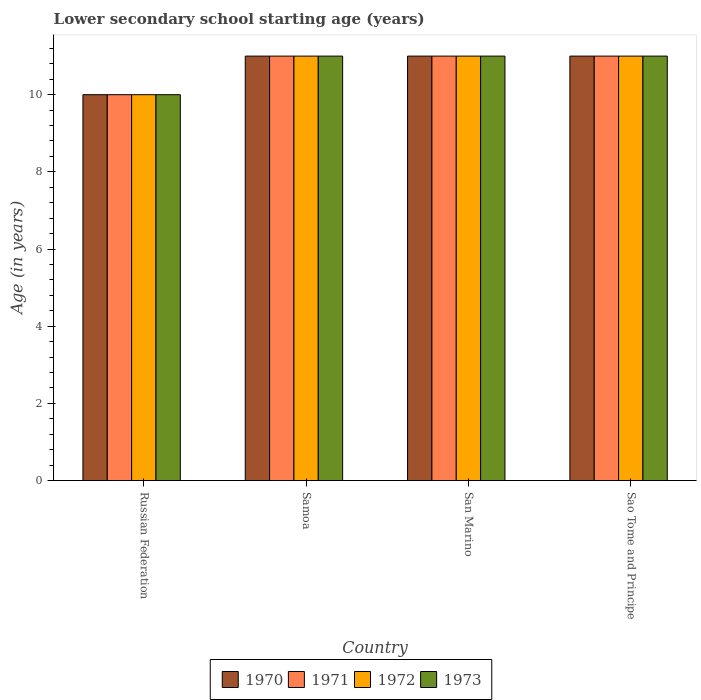How many different coloured bars are there?
Your answer should be compact. 4. How many groups of bars are there?
Offer a very short reply. 4. Are the number of bars per tick equal to the number of legend labels?
Keep it short and to the point. Yes. How many bars are there on the 3rd tick from the right?
Make the answer very short. 4. What is the label of the 4th group of bars from the left?
Your answer should be very brief. Sao Tome and Principe. What is the lower secondary school starting age of children in 1970 in Sao Tome and Principe?
Keep it short and to the point. 11. Across all countries, what is the maximum lower secondary school starting age of children in 1970?
Make the answer very short. 11. Across all countries, what is the minimum lower secondary school starting age of children in 1970?
Your response must be concise. 10. In which country was the lower secondary school starting age of children in 1972 maximum?
Your answer should be compact. Samoa. In which country was the lower secondary school starting age of children in 1973 minimum?
Your response must be concise. Russian Federation. What is the difference between the lower secondary school starting age of children in 1970 in Sao Tome and Principe and the lower secondary school starting age of children in 1972 in Samoa?
Offer a terse response. 0. What is the average lower secondary school starting age of children in 1973 per country?
Offer a terse response. 10.75. What is the difference between the lower secondary school starting age of children of/in 1972 and lower secondary school starting age of children of/in 1970 in San Marino?
Provide a succinct answer. 0. Is the difference between the lower secondary school starting age of children in 1972 in San Marino and Sao Tome and Principe greater than the difference between the lower secondary school starting age of children in 1970 in San Marino and Sao Tome and Principe?
Offer a terse response. No. What is the difference between the highest and the lowest lower secondary school starting age of children in 1973?
Provide a succinct answer. 1. Is the sum of the lower secondary school starting age of children in 1972 in Samoa and Sao Tome and Principe greater than the maximum lower secondary school starting age of children in 1971 across all countries?
Your answer should be compact. Yes. Is it the case that in every country, the sum of the lower secondary school starting age of children in 1971 and lower secondary school starting age of children in 1970 is greater than the sum of lower secondary school starting age of children in 1973 and lower secondary school starting age of children in 1972?
Make the answer very short. No. What does the 2nd bar from the left in Sao Tome and Principe represents?
Make the answer very short. 1971. What does the 3rd bar from the right in San Marino represents?
Your answer should be compact. 1971. What is the difference between two consecutive major ticks on the Y-axis?
Give a very brief answer. 2. Does the graph contain any zero values?
Provide a succinct answer. No. Does the graph contain grids?
Offer a very short reply. No. Where does the legend appear in the graph?
Your answer should be compact. Bottom center. How many legend labels are there?
Offer a terse response. 4. What is the title of the graph?
Provide a short and direct response. Lower secondary school starting age (years). Does "2000" appear as one of the legend labels in the graph?
Your answer should be very brief. No. What is the label or title of the Y-axis?
Make the answer very short. Age (in years). What is the Age (in years) of 1972 in Russian Federation?
Keep it short and to the point. 10. What is the Age (in years) in 1971 in Samoa?
Make the answer very short. 11. What is the Age (in years) of 1973 in Samoa?
Offer a very short reply. 11. What is the Age (in years) of 1971 in San Marino?
Offer a terse response. 11. What is the Age (in years) in 1970 in Sao Tome and Principe?
Provide a succinct answer. 11. Across all countries, what is the maximum Age (in years) of 1970?
Your answer should be compact. 11. Across all countries, what is the maximum Age (in years) in 1972?
Offer a very short reply. 11. Across all countries, what is the minimum Age (in years) in 1970?
Your response must be concise. 10. Across all countries, what is the minimum Age (in years) in 1971?
Keep it short and to the point. 10. Across all countries, what is the minimum Age (in years) in 1972?
Keep it short and to the point. 10. What is the total Age (in years) of 1971 in the graph?
Keep it short and to the point. 43. What is the total Age (in years) in 1973 in the graph?
Offer a very short reply. 43. What is the difference between the Age (in years) in 1973 in Russian Federation and that in Samoa?
Provide a short and direct response. -1. What is the difference between the Age (in years) of 1971 in Russian Federation and that in San Marino?
Make the answer very short. -1. What is the difference between the Age (in years) in 1972 in Russian Federation and that in San Marino?
Offer a terse response. -1. What is the difference between the Age (in years) of 1970 in Russian Federation and that in Sao Tome and Principe?
Your response must be concise. -1. What is the difference between the Age (in years) of 1971 in Russian Federation and that in Sao Tome and Principe?
Make the answer very short. -1. What is the difference between the Age (in years) in 1972 in Russian Federation and that in Sao Tome and Principe?
Offer a terse response. -1. What is the difference between the Age (in years) in 1973 in Russian Federation and that in Sao Tome and Principe?
Give a very brief answer. -1. What is the difference between the Age (in years) of 1970 in Samoa and that in Sao Tome and Principe?
Your answer should be very brief. 0. What is the difference between the Age (in years) in 1971 in Samoa and that in Sao Tome and Principe?
Offer a terse response. 0. What is the difference between the Age (in years) in 1973 in Samoa and that in Sao Tome and Principe?
Your answer should be very brief. 0. What is the difference between the Age (in years) of 1970 in San Marino and that in Sao Tome and Principe?
Offer a terse response. 0. What is the difference between the Age (in years) in 1971 in San Marino and that in Sao Tome and Principe?
Your answer should be compact. 0. What is the difference between the Age (in years) of 1970 in Russian Federation and the Age (in years) of 1972 in Samoa?
Offer a very short reply. -1. What is the difference between the Age (in years) in 1971 in Russian Federation and the Age (in years) in 1973 in Samoa?
Your answer should be very brief. -1. What is the difference between the Age (in years) in 1970 in Russian Federation and the Age (in years) in 1972 in San Marino?
Offer a very short reply. -1. What is the difference between the Age (in years) of 1970 in Russian Federation and the Age (in years) of 1973 in San Marino?
Your response must be concise. -1. What is the difference between the Age (in years) of 1971 in Russian Federation and the Age (in years) of 1972 in San Marino?
Your answer should be very brief. -1. What is the difference between the Age (in years) of 1970 in Russian Federation and the Age (in years) of 1971 in Sao Tome and Principe?
Keep it short and to the point. -1. What is the difference between the Age (in years) of 1970 in Russian Federation and the Age (in years) of 1972 in Sao Tome and Principe?
Your answer should be compact. -1. What is the difference between the Age (in years) in 1970 in Russian Federation and the Age (in years) in 1973 in Sao Tome and Principe?
Make the answer very short. -1. What is the difference between the Age (in years) of 1971 in Russian Federation and the Age (in years) of 1973 in Sao Tome and Principe?
Keep it short and to the point. -1. What is the difference between the Age (in years) in 1970 in Samoa and the Age (in years) in 1971 in San Marino?
Offer a terse response. 0. What is the difference between the Age (in years) in 1970 in Samoa and the Age (in years) in 1972 in San Marino?
Your answer should be compact. 0. What is the difference between the Age (in years) of 1970 in Samoa and the Age (in years) of 1973 in San Marino?
Give a very brief answer. 0. What is the difference between the Age (in years) of 1971 in Samoa and the Age (in years) of 1972 in San Marino?
Offer a very short reply. 0. What is the difference between the Age (in years) in 1971 in Samoa and the Age (in years) in 1973 in Sao Tome and Principe?
Offer a terse response. 0. What is the difference between the Age (in years) in 1970 in San Marino and the Age (in years) in 1973 in Sao Tome and Principe?
Your answer should be very brief. 0. What is the average Age (in years) in 1970 per country?
Provide a short and direct response. 10.75. What is the average Age (in years) in 1971 per country?
Make the answer very short. 10.75. What is the average Age (in years) of 1972 per country?
Your answer should be very brief. 10.75. What is the average Age (in years) of 1973 per country?
Offer a very short reply. 10.75. What is the difference between the Age (in years) of 1970 and Age (in years) of 1972 in Russian Federation?
Your answer should be compact. 0. What is the difference between the Age (in years) of 1972 and Age (in years) of 1973 in Russian Federation?
Make the answer very short. 0. What is the difference between the Age (in years) of 1970 and Age (in years) of 1972 in Samoa?
Keep it short and to the point. 0. What is the difference between the Age (in years) in 1970 and Age (in years) in 1973 in Samoa?
Offer a terse response. 0. What is the difference between the Age (in years) of 1971 and Age (in years) of 1972 in Samoa?
Provide a succinct answer. 0. What is the difference between the Age (in years) of 1972 and Age (in years) of 1973 in Samoa?
Offer a very short reply. 0. What is the difference between the Age (in years) in 1970 and Age (in years) in 1973 in San Marino?
Your answer should be compact. 0. What is the difference between the Age (in years) in 1971 and Age (in years) in 1973 in San Marino?
Ensure brevity in your answer.  0. What is the difference between the Age (in years) of 1970 and Age (in years) of 1971 in Sao Tome and Principe?
Your answer should be very brief. 0. What is the difference between the Age (in years) of 1970 and Age (in years) of 1973 in Sao Tome and Principe?
Provide a succinct answer. 0. What is the difference between the Age (in years) in 1971 and Age (in years) in 1972 in Sao Tome and Principe?
Provide a succinct answer. 0. What is the difference between the Age (in years) in 1972 and Age (in years) in 1973 in Sao Tome and Principe?
Give a very brief answer. 0. What is the ratio of the Age (in years) in 1970 in Russian Federation to that in Samoa?
Give a very brief answer. 0.91. What is the ratio of the Age (in years) in 1971 in Russian Federation to that in Samoa?
Make the answer very short. 0.91. What is the ratio of the Age (in years) of 1972 in Russian Federation to that in Samoa?
Your response must be concise. 0.91. What is the ratio of the Age (in years) in 1973 in Russian Federation to that in Samoa?
Ensure brevity in your answer.  0.91. What is the ratio of the Age (in years) in 1971 in Russian Federation to that in San Marino?
Make the answer very short. 0.91. What is the ratio of the Age (in years) of 1970 in Russian Federation to that in Sao Tome and Principe?
Make the answer very short. 0.91. What is the ratio of the Age (in years) of 1971 in Russian Federation to that in Sao Tome and Principe?
Your answer should be compact. 0.91. What is the ratio of the Age (in years) of 1972 in Russian Federation to that in Sao Tome and Principe?
Your response must be concise. 0.91. What is the ratio of the Age (in years) in 1973 in Russian Federation to that in Sao Tome and Principe?
Provide a short and direct response. 0.91. What is the ratio of the Age (in years) of 1972 in Samoa to that in San Marino?
Your response must be concise. 1. What is the ratio of the Age (in years) in 1972 in Samoa to that in Sao Tome and Principe?
Your answer should be compact. 1. What is the ratio of the Age (in years) in 1973 in Samoa to that in Sao Tome and Principe?
Your answer should be very brief. 1. What is the ratio of the Age (in years) of 1971 in San Marino to that in Sao Tome and Principe?
Your response must be concise. 1. What is the difference between the highest and the second highest Age (in years) in 1970?
Offer a very short reply. 0. What is the difference between the highest and the second highest Age (in years) in 1971?
Your answer should be compact. 0. What is the difference between the highest and the second highest Age (in years) in 1972?
Provide a short and direct response. 0. What is the difference between the highest and the lowest Age (in years) of 1970?
Give a very brief answer. 1. What is the difference between the highest and the lowest Age (in years) in 1971?
Ensure brevity in your answer.  1. What is the difference between the highest and the lowest Age (in years) of 1973?
Provide a succinct answer. 1. 